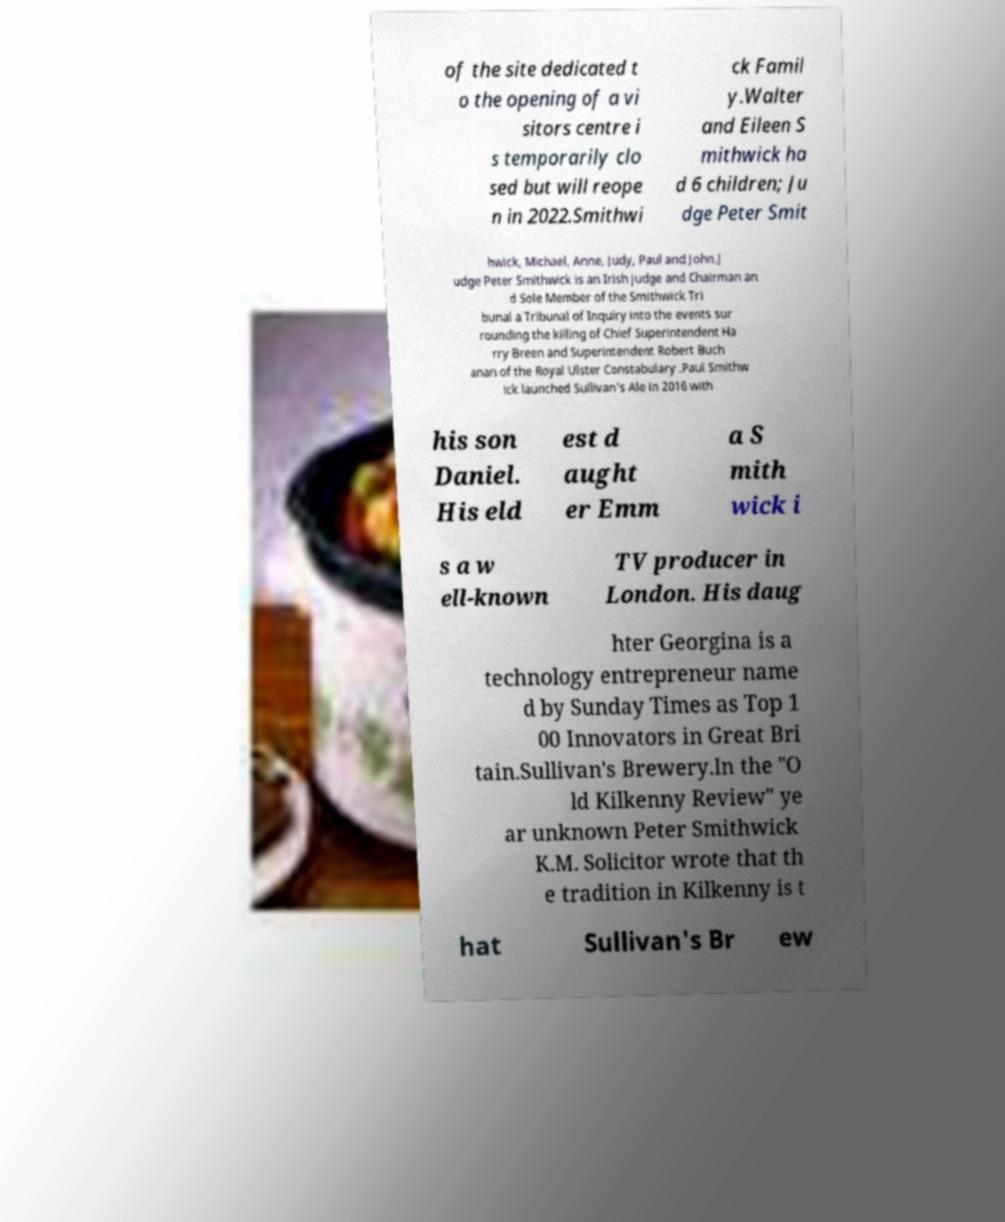Could you assist in decoding the text presented in this image and type it out clearly? of the site dedicated t o the opening of a vi sitors centre i s temporarily clo sed but will reope n in 2022.Smithwi ck Famil y.Walter and Eileen S mithwick ha d 6 children; Ju dge Peter Smit hwick, Michael, Anne, Judy, Paul and John.J udge Peter Smithwick is an Irish judge and Chairman an d Sole Member of the Smithwick Tri bunal a Tribunal of Inquiry into the events sur rounding the killing of Chief Superintendent Ha rry Breen and Superintendent Robert Buch anan of the Royal Ulster Constabulary .Paul Smithw ick launched Sullivan's Ale in 2016 with his son Daniel. His eld est d aught er Emm a S mith wick i s a w ell-known TV producer in London. His daug hter Georgina is a technology entrepreneur name d by Sunday Times as Top 1 00 Innovators in Great Bri tain.Sullivan's Brewery.In the "O ld Kilkenny Review" ye ar unknown Peter Smithwick K.M. Solicitor wrote that th e tradition in Kilkenny is t hat Sullivan's Br ew 